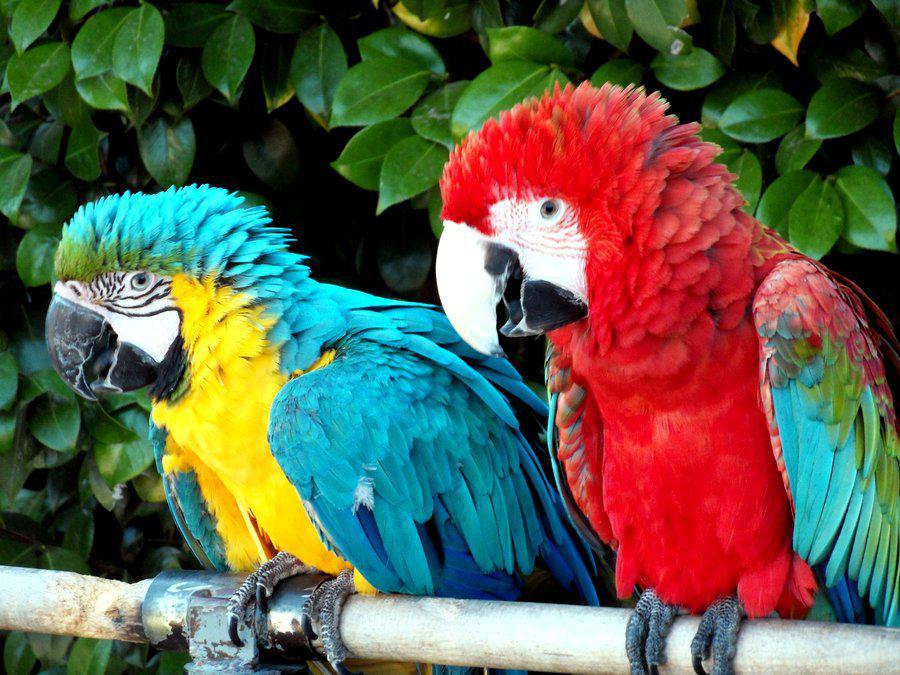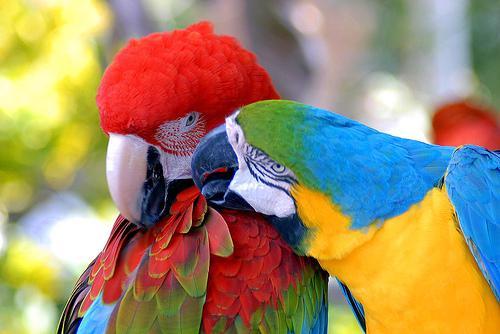The first image is the image on the left, the second image is the image on the right. Considering the images on both sides, is "In the paired images, only parrots with spread wings are shown." valid? Answer yes or no. No. The first image is the image on the left, the second image is the image on the right. Considering the images on both sides, is "At least one of the images has two birds standing on the same branch." valid? Answer yes or no. Yes. The first image is the image on the left, the second image is the image on the right. Examine the images to the left and right. Is the description "The parrot in the right image is flying." accurate? Answer yes or no. No. 